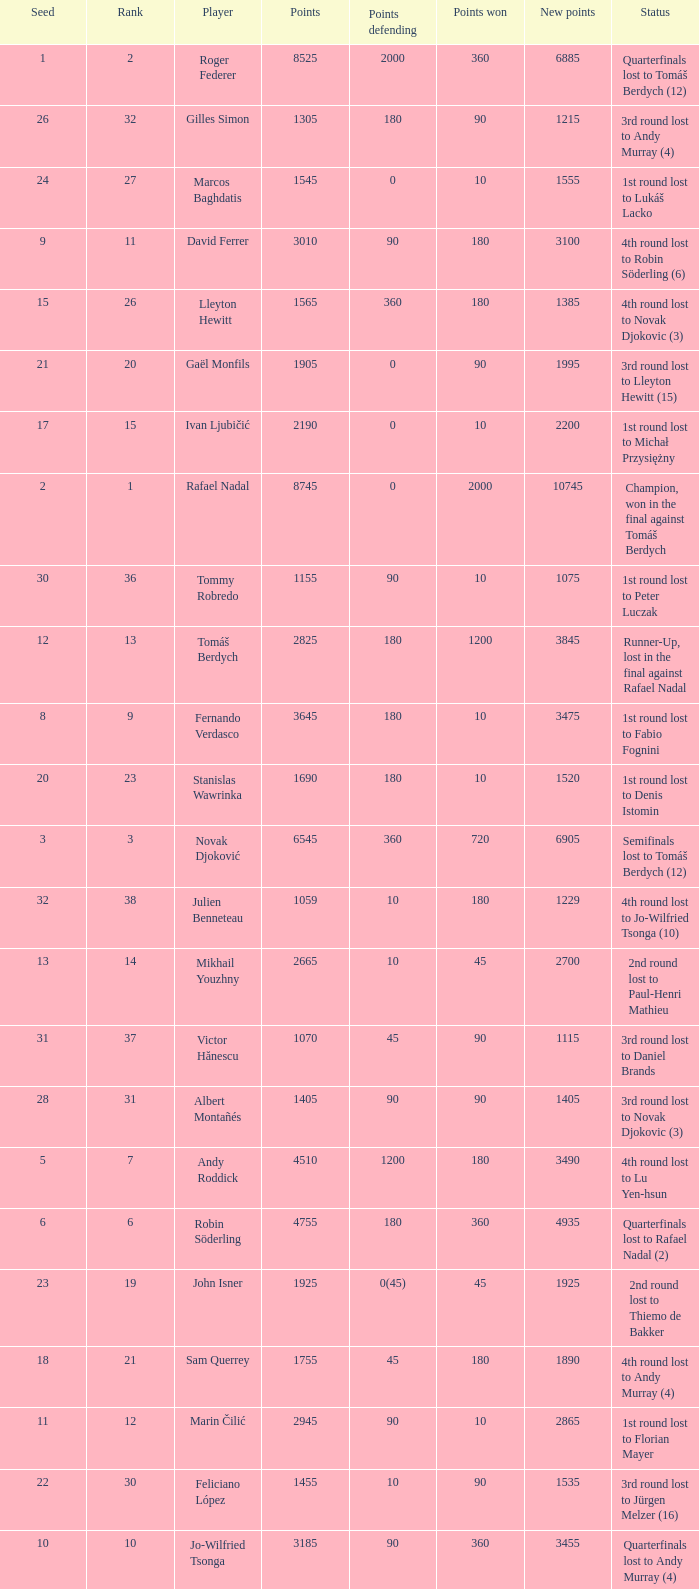Name the number of points defending for 1075 1.0. 